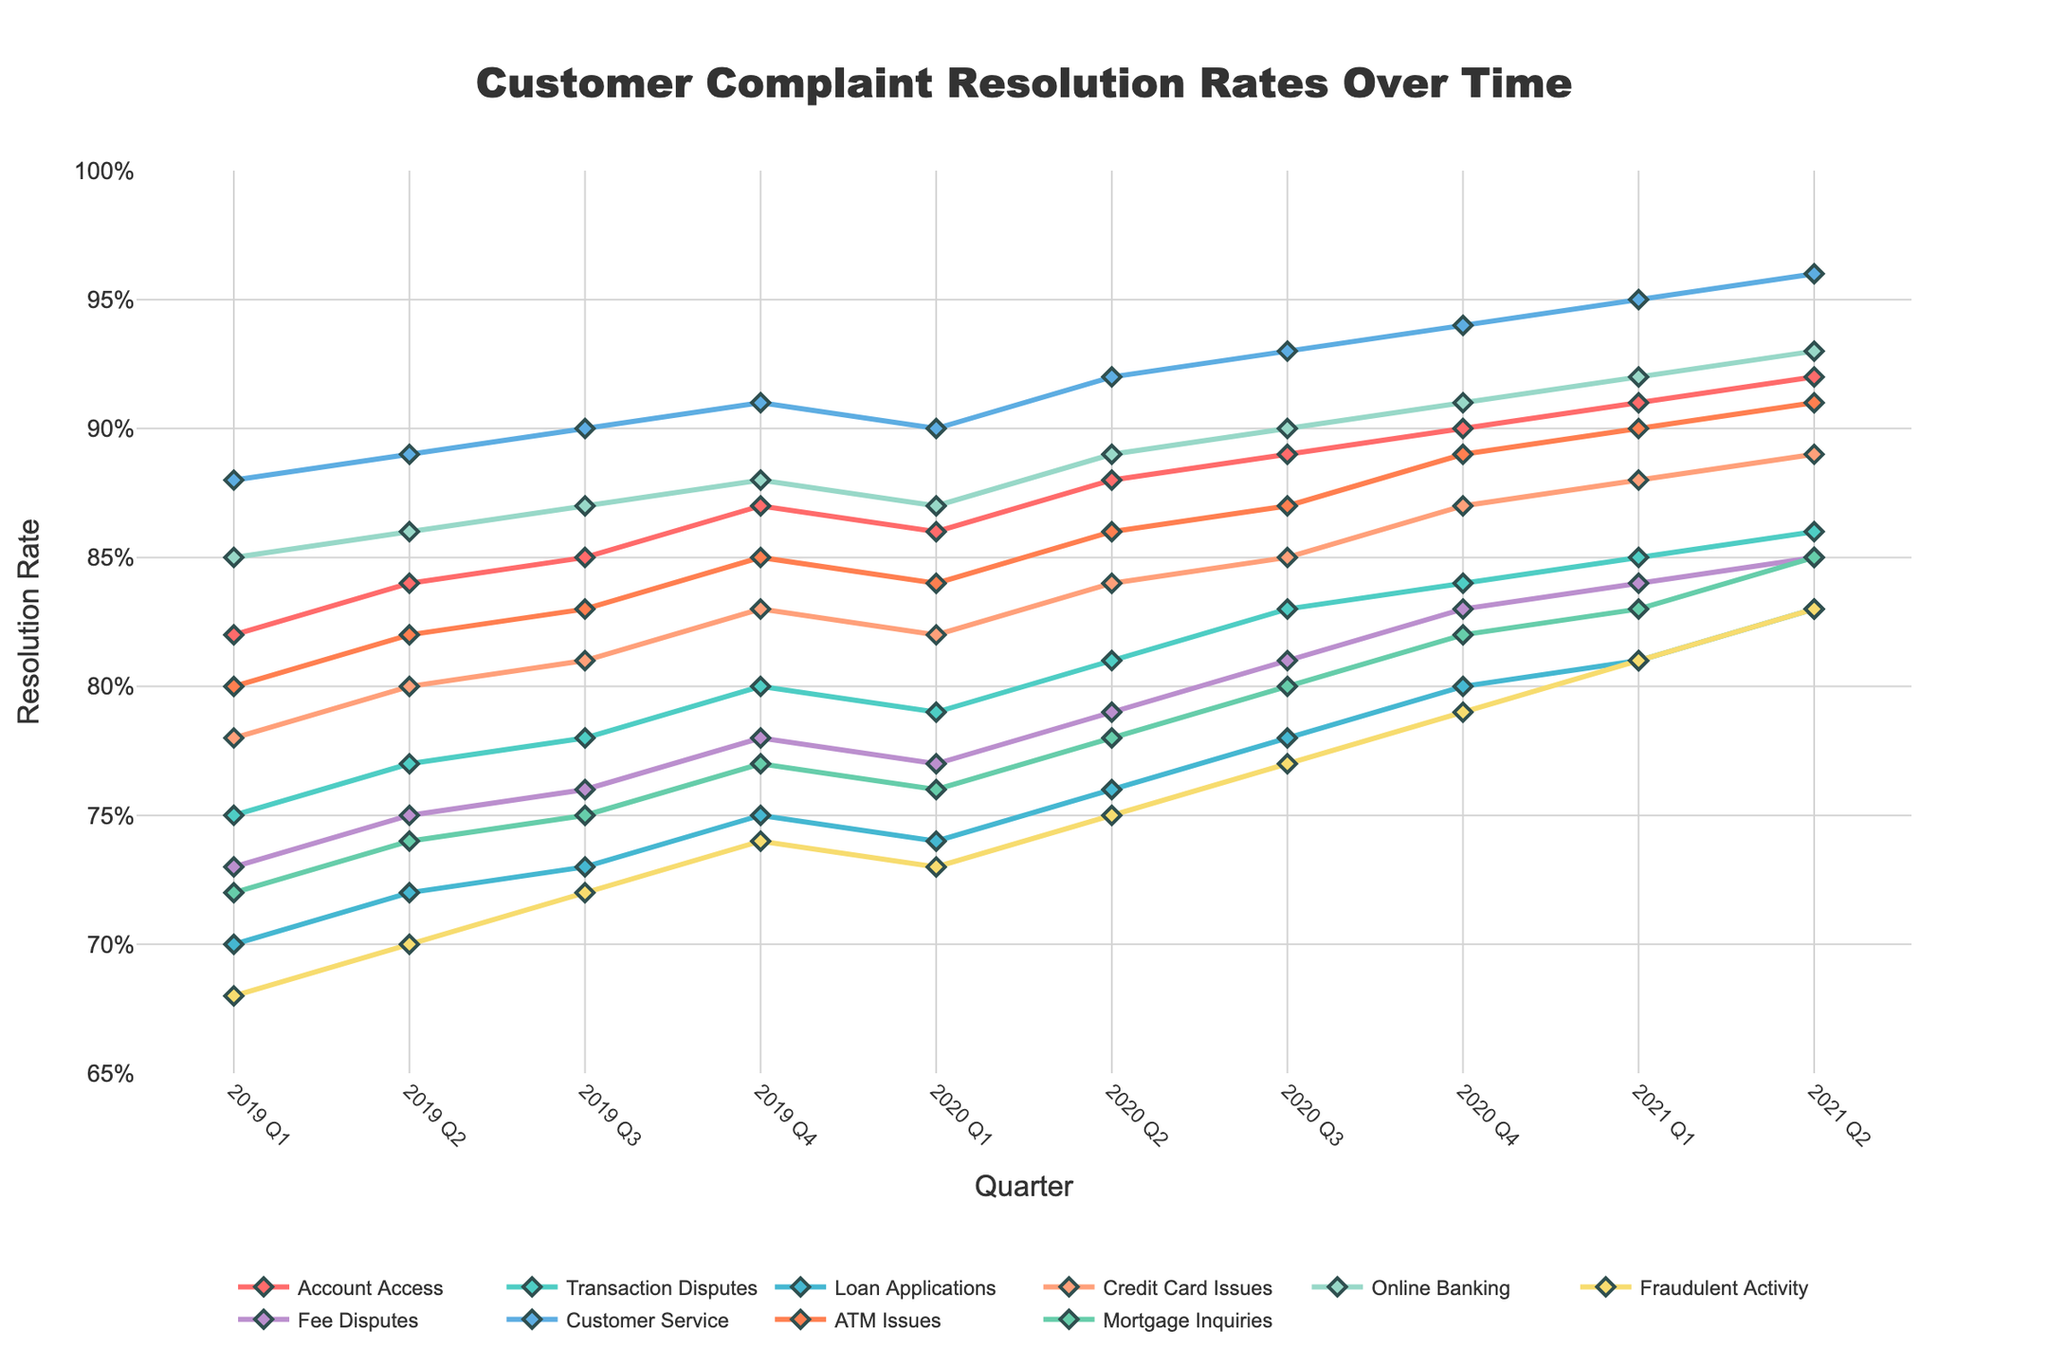Which issue type had the highest resolution rate in 2021 Q2? To find the issue type with the highest resolution rate in 2021 Q2, look at the highest point in the last column. The highest rate is 96% for Customer Service.
Answer: Customer Service Which two issue types showed an increase in resolution rates in every quarter from 2019 Q1 to 2021 Q2? To determine which issue types increased every quarter, trace each line for consistent upward slopes. Both Customer Service and Online Banking consistently increased each quarter.
Answer: Customer Service, Online Banking What is the difference in the resolution rates of Fraudulent Activity between 2020 Q2 and 2021 Q2? Locate the points for Fraudulent Activity in 2020 Q2 (75%) and 2021 Q2 (83%). Subtract the former from the latter: 83% - 75% = 8%.
Answer: 8% How does the resolution rate of Loan Applications in 2019 Q4 compare to Transaction Disputes in 2021 Q1? Look at Loan Applications in 2019 Q4 (75%) and Transaction Disputes in 2021 Q1 (85%). Compare the two values: 75% is less than 85%.
Answer: Loan Applications in 2019 Q4 is less than Transaction Disputes in 2021 Q1 Which issue type had a higher resolution rate in 2020 Q1 compared to ATM Issues? By how much? ATM Issues in 2020 Q1 is 84%. Compare against other issue types: Account Access (86%), Credit Card Issues (82%), Online Banking (87%), Fraudulent Activity (73%), Fee Disputes (77%), Customer Service (90%), Mortgage Inquiries (76%), Transaction Disputes (79%), and Loan Applications (74%). Identify higher: Account Access (86%), Customer Service (90%), Online Banking (87%). The highest difference: Customer Service - ATM Issues: 90% - 84% = 6%.
Answer: Customer Service, 6% What is the average resolution rate for Credit Card Issues over the period shown? Add up the resolution rates for Credit Card Issues: 78% + 80% + 81% + 83% + 82% + 84% + 85% + 87% + 88% + 89% = 837%. Divide by the number of quarters (10): 837% / 10 = 83.7%.
Answer: 83.7% Which issue type had the smallest increase in resolution rate from 2019 Q1 to 2021 Q2? Calculate the increase for each issue type by subtracting the 2019 Q1 rate from the 2021 Q2 rate. Identify the smallest increase: Account Access (10%), Transaction Disputes (11%), Loan Applications (13%), Credit Card Issues (11%), Online Banking (8%), Fraudulent Activity (15%), Fee Disputes (12%), Customer Service (8%), ATM Issues (11%), Mortgage Inquiries (13%). Online Banking and Customer Service both have the smallest increase of 8%.
Answer: Online Banking, Customer Service 